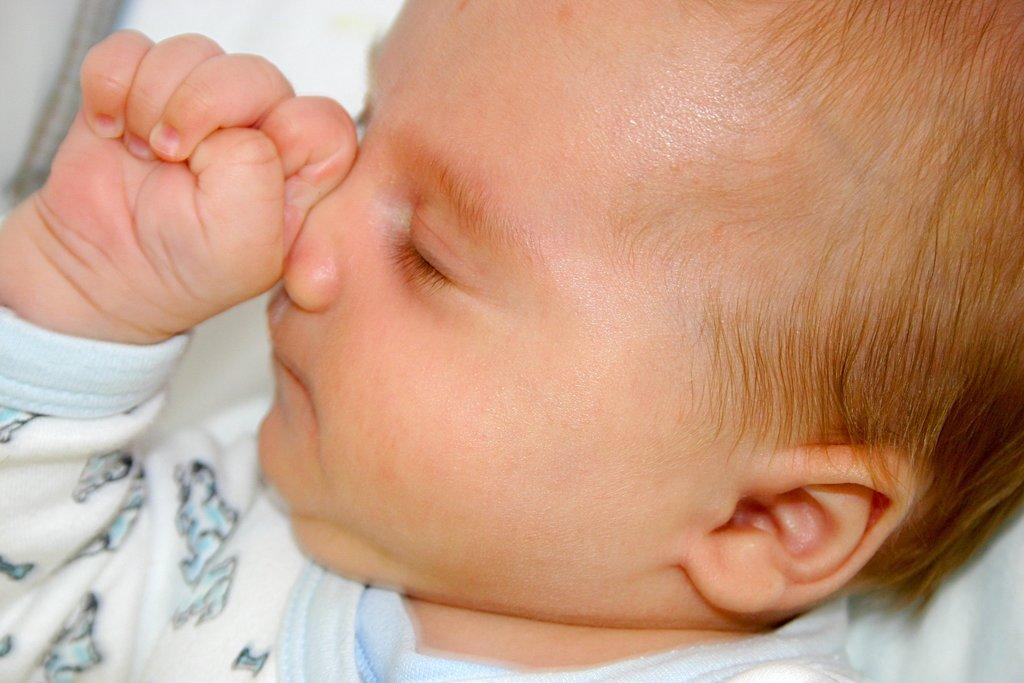What is the main subject of the image? The main subject of the image is a kid. What type of car is the kid driving in the image? There is no car present in the image; the main subject is a kid. Is there a bear accompanying the kid in the image? There is no bear present in the image; the main subject is a kid. 